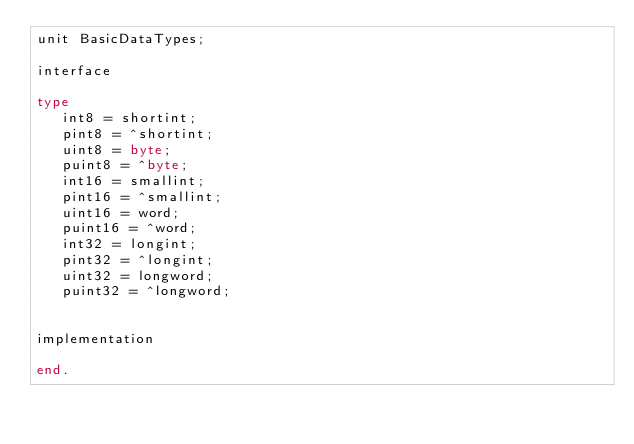<code> <loc_0><loc_0><loc_500><loc_500><_Pascal_>unit BasicDataTypes;

interface

type
   int8 = shortint;
   pint8 = ^shortint;
   uint8 = byte;
   puint8 = ^byte;
   int16 = smallint;
   pint16 = ^smallint;
   uint16 = word;
   puint16 = ^word;
   int32 = longint;
   pint32 = ^longint;
   uint32 = longword;
   puint32 = ^longword;


implementation

end.
</code> 